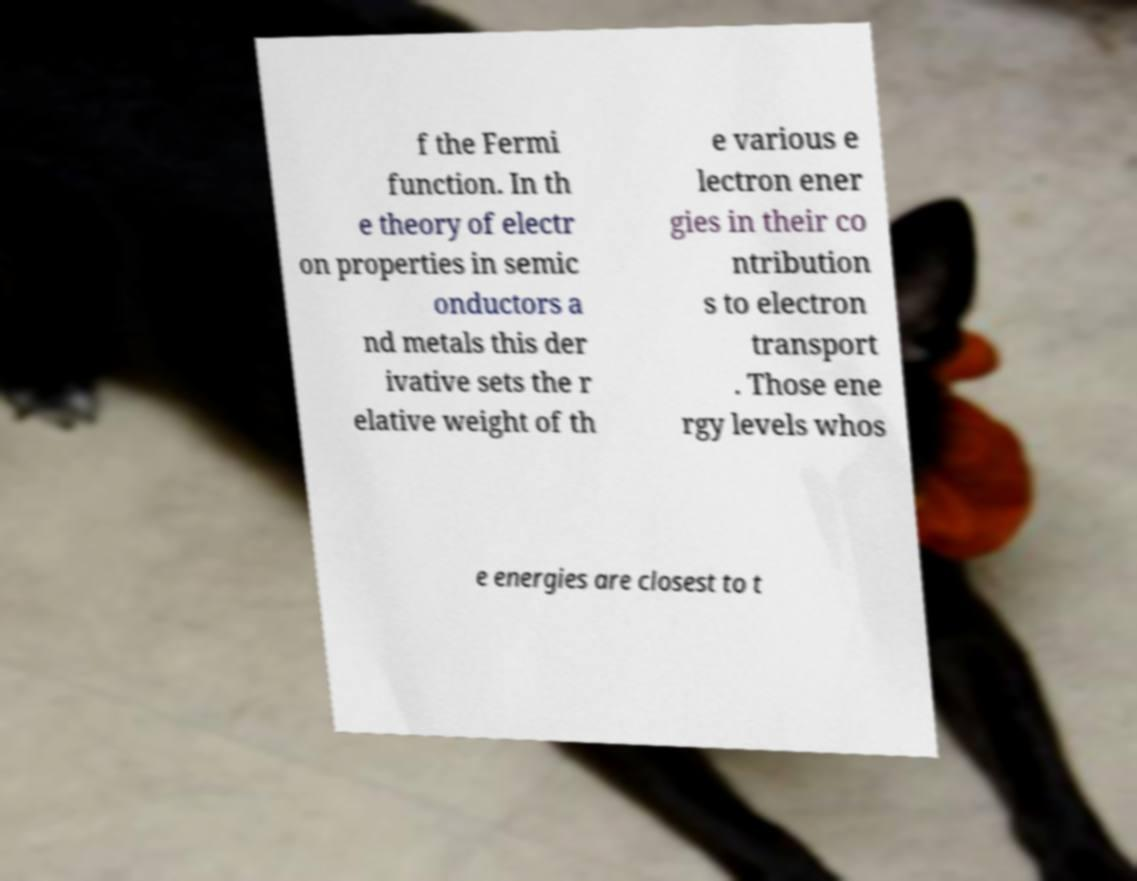Can you read and provide the text displayed in the image?This photo seems to have some interesting text. Can you extract and type it out for me? f the Fermi function. In th e theory of electr on properties in semic onductors a nd metals this der ivative sets the r elative weight of th e various e lectron ener gies in their co ntribution s to electron transport . Those ene rgy levels whos e energies are closest to t 